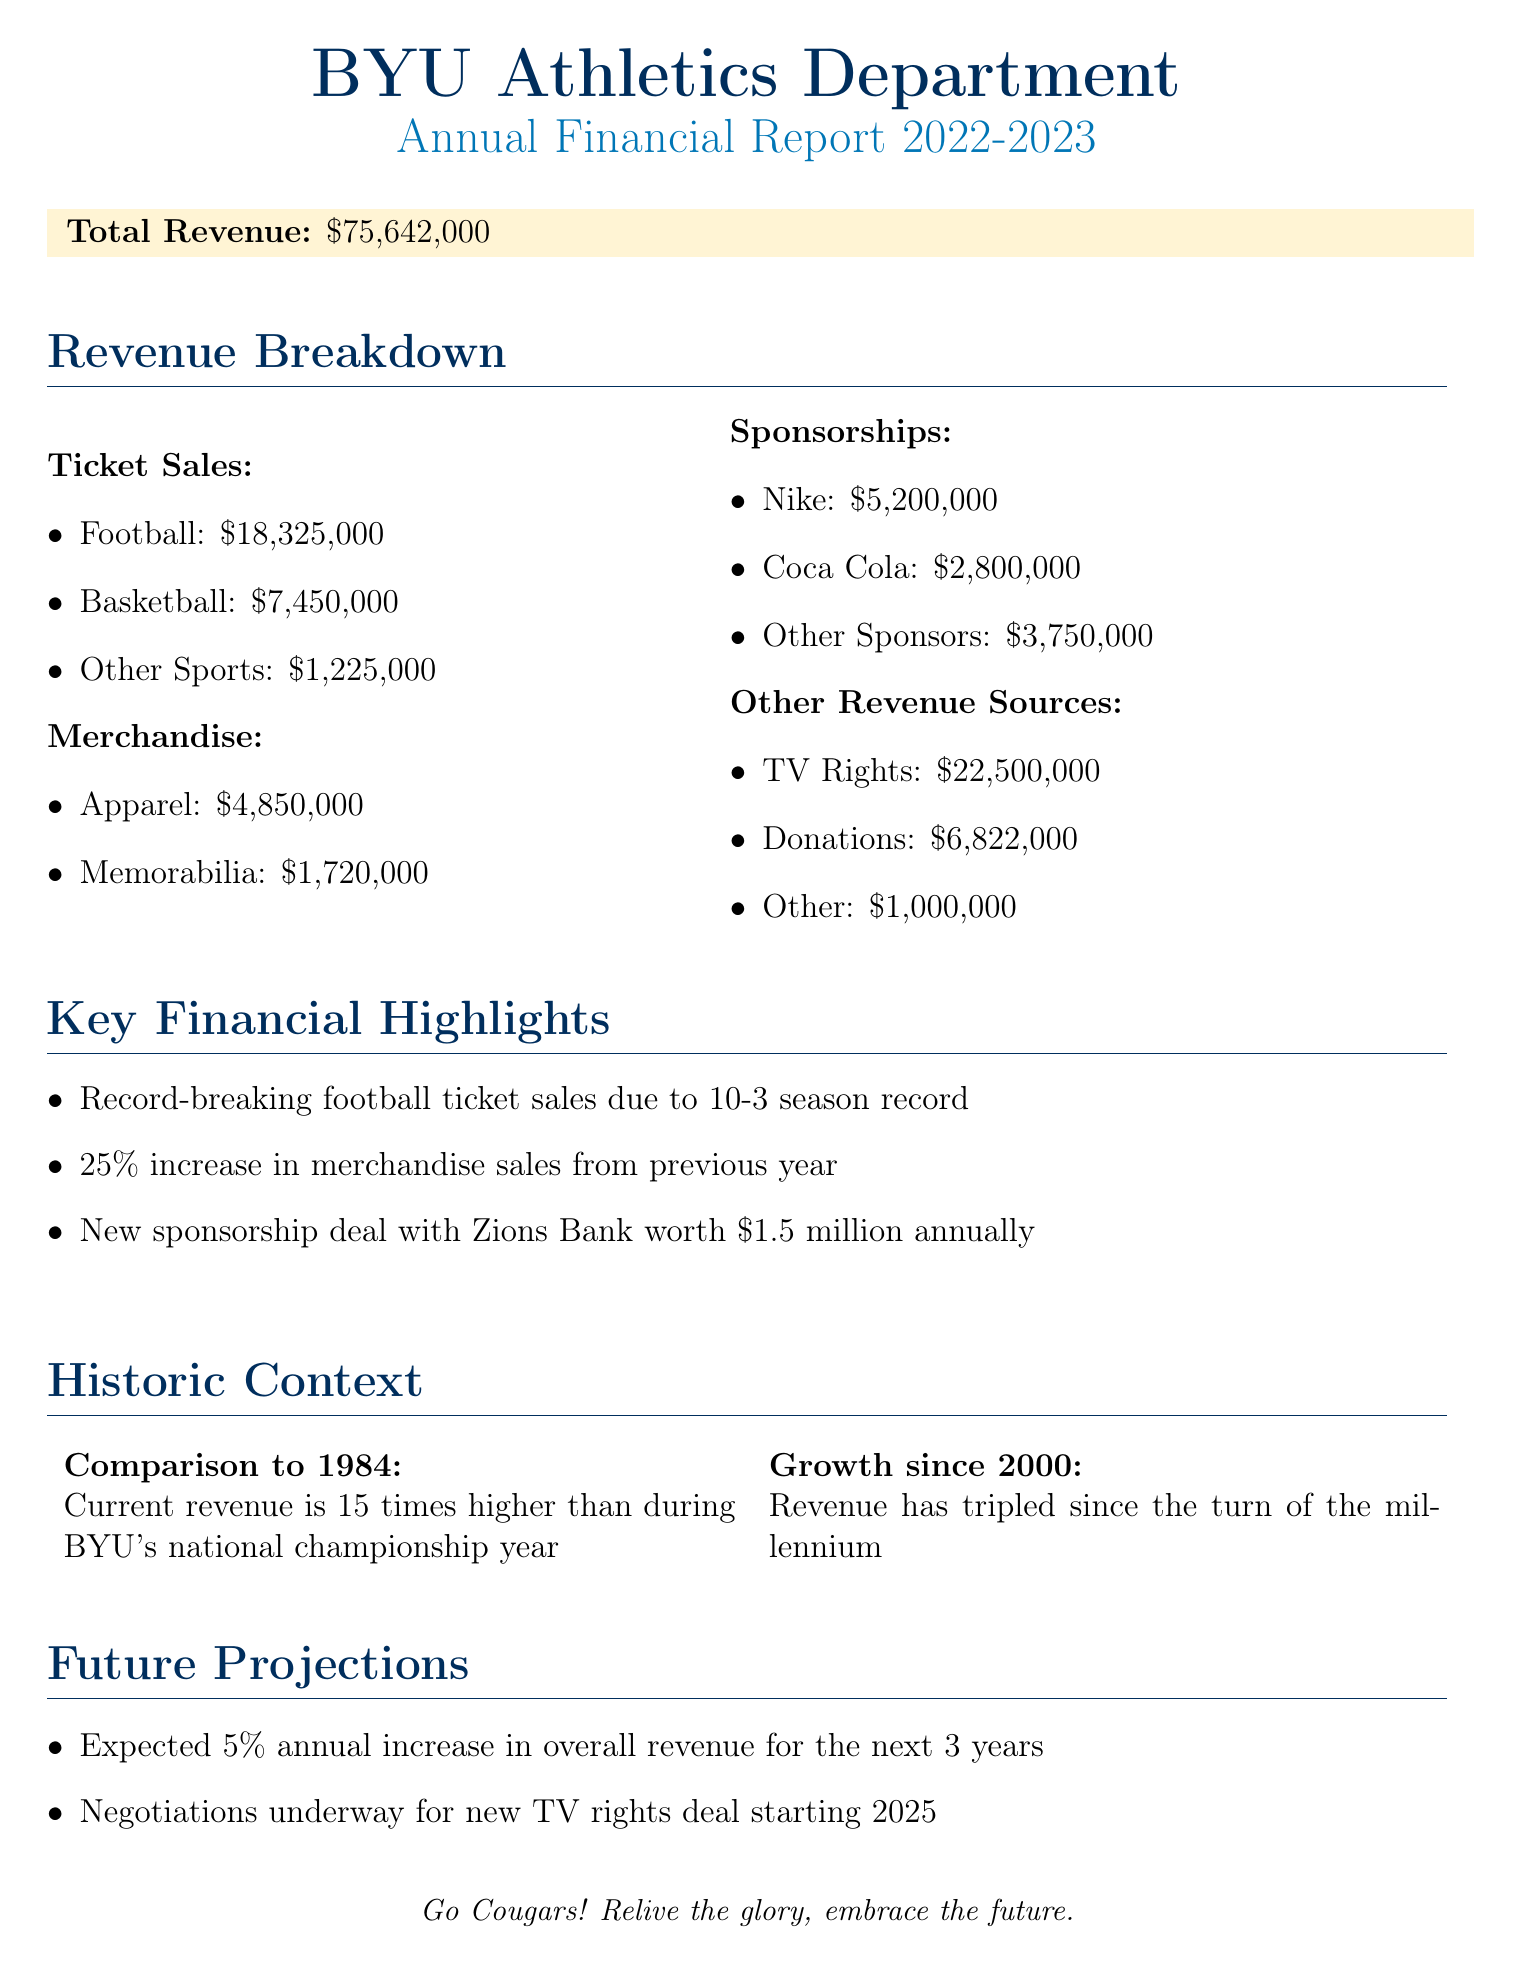What is the total revenue? The total revenue is presented as the overall figure at the beginning of the financial report.
Answer: $75,642,000 How much was generated from football ticket sales? The revenue from football ticket sales is listed under the ticket sales section of the document.
Answer: $18,325,000 What percentage increase was reported in merchandise sales? The percentage increase in merchandise sales is noted as part of the key financial highlights section.
Answer: 25% What are the total donations received? The total donations amount is specified in the revenue breakdown under other revenue sources.
Answer: $6,822,000 Which company's sponsorship deal is worth $1.5 million annually? The new sponsorship deal details are provided in the key financial highlights section of the report.
Answer: Zions Bank How does the current revenue compare to 1984? The comparison of current revenue to that of 1984 is summarized in the historic context section.
Answer: 15 times higher What is the expected annual revenue growth for the next 3 years? This expectation is mentioned in the future projections section of the report.
Answer: 5% How much revenue came from TV rights? The revenue from TV rights is specifically listed under other revenue sources in the report.
Answer: $22,500,000 What was the revenue from memorabilia sales? The revenue from memorabilia is outlined in the merchandise section of the revenue breakdown.
Answer: $1,720,000 What was the growth in revenue since the year 2000? This growth figure is described in the historic context section of the report.
Answer: Tripled 